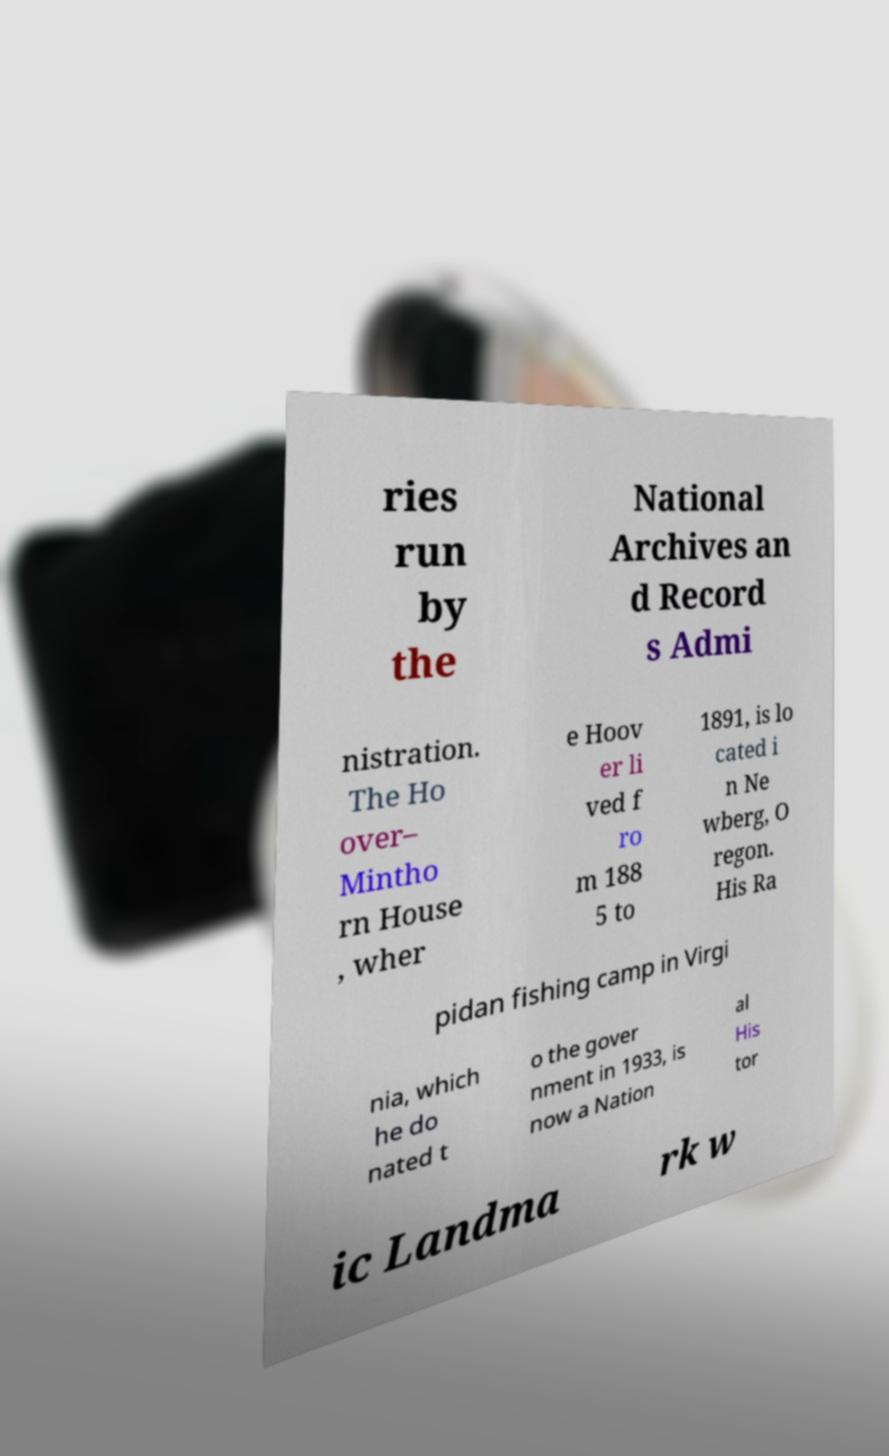Can you accurately transcribe the text from the provided image for me? ries run by the National Archives an d Record s Admi nistration. The Ho over– Mintho rn House , wher e Hoov er li ved f ro m 188 5 to 1891, is lo cated i n Ne wberg, O regon. His Ra pidan fishing camp in Virgi nia, which he do nated t o the gover nment in 1933, is now a Nation al His tor ic Landma rk w 